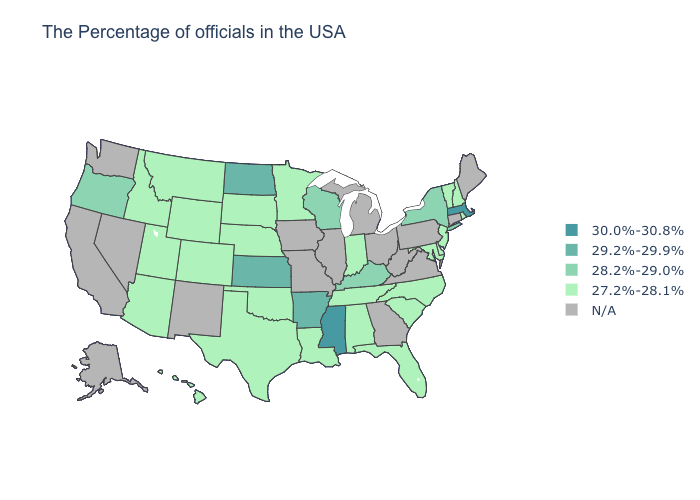What is the value of Utah?
Give a very brief answer. 27.2%-28.1%. Does the map have missing data?
Keep it brief. Yes. What is the value of Connecticut?
Short answer required. N/A. Name the states that have a value in the range 30.0%-30.8%?
Short answer required. Massachusetts, Mississippi. Among the states that border Virginia , does Maryland have the lowest value?
Give a very brief answer. Yes. Name the states that have a value in the range 28.2%-29.0%?
Write a very short answer. New York, Kentucky, Wisconsin, Oregon. What is the value of Kansas?
Be succinct. 29.2%-29.9%. Name the states that have a value in the range N/A?
Quick response, please. Maine, Connecticut, Pennsylvania, Virginia, West Virginia, Ohio, Georgia, Michigan, Illinois, Missouri, Iowa, New Mexico, Nevada, California, Washington, Alaska. Does Louisiana have the lowest value in the South?
Write a very short answer. Yes. What is the value of Alabama?
Short answer required. 27.2%-28.1%. What is the highest value in states that border Tennessee?
Give a very brief answer. 30.0%-30.8%. What is the value of Arizona?
Concise answer only. 27.2%-28.1%. Does the map have missing data?
Short answer required. Yes. Which states have the highest value in the USA?
Keep it brief. Massachusetts, Mississippi. 